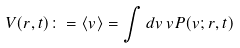Convert formula to latex. <formula><loc_0><loc_0><loc_500><loc_500>V ( r , t ) \colon = \langle v \rangle = \int d v \, v P ( v ; r , t )</formula> 